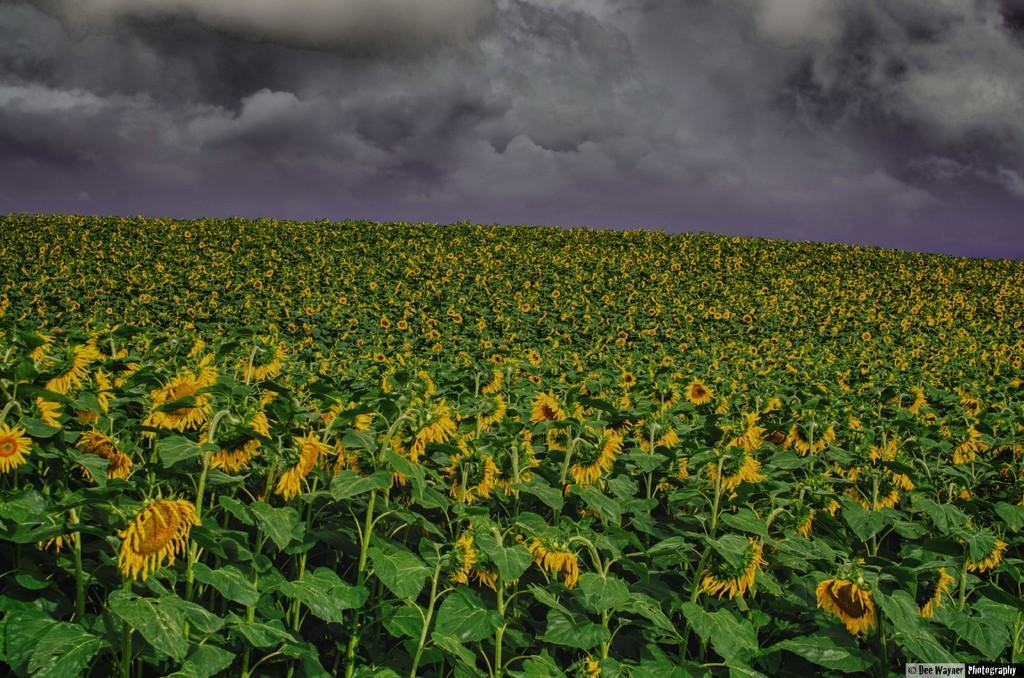Can you describe this image briefly? In this image we can see a sunflower farm. In the background we can see sky with clouds. 